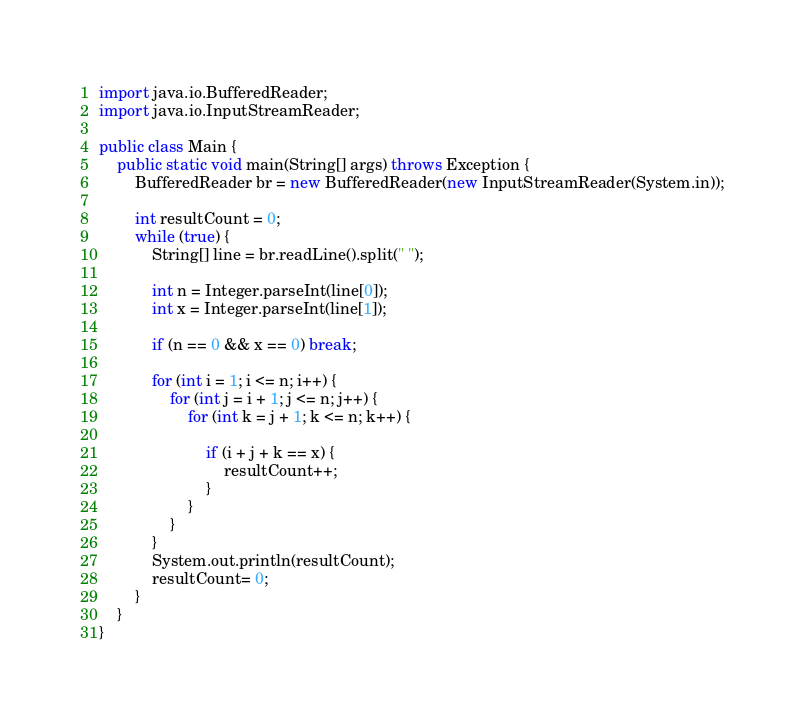<code> <loc_0><loc_0><loc_500><loc_500><_Java_>import java.io.BufferedReader;
import java.io.InputStreamReader;

public class Main {
	public static void main(String[] args) throws Exception {
	    BufferedReader br = new BufferedReader(new InputStreamReader(System.in));

	    int resultCount = 0;
	    while (true) {
		    String[] line = br.readLine().split(" ");

		    int n = Integer.parseInt(line[0]);
		    int x = Integer.parseInt(line[1]);

		    if (n == 0 && x == 0) break;

		    for (int i = 1; i <= n; i++) {
		    	for (int j = i + 1; j <= n; j++) {
		    		for (int k = j + 1; k <= n; k++) {

		    			if (i + j + k == x) {
		    				resultCount++;
		    			}
		    		}
		    	}
		    }
		    System.out.println(resultCount);
		    resultCount= 0;
	    }
	}
}</code> 